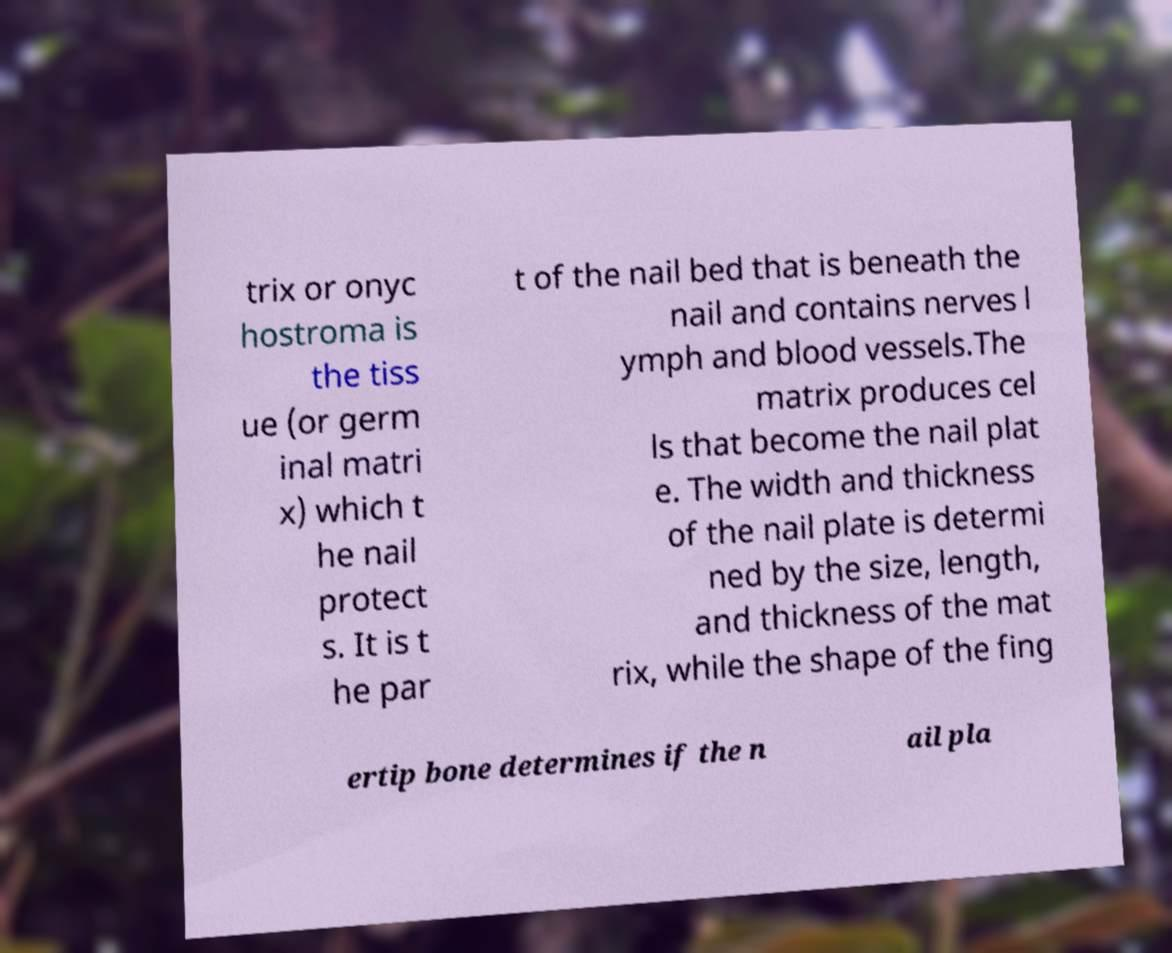I need the written content from this picture converted into text. Can you do that? trix or onyc hostroma is the tiss ue (or germ inal matri x) which t he nail protect s. It is t he par t of the nail bed that is beneath the nail and contains nerves l ymph and blood vessels.The matrix produces cel ls that become the nail plat e. The width and thickness of the nail plate is determi ned by the size, length, and thickness of the mat rix, while the shape of the fing ertip bone determines if the n ail pla 